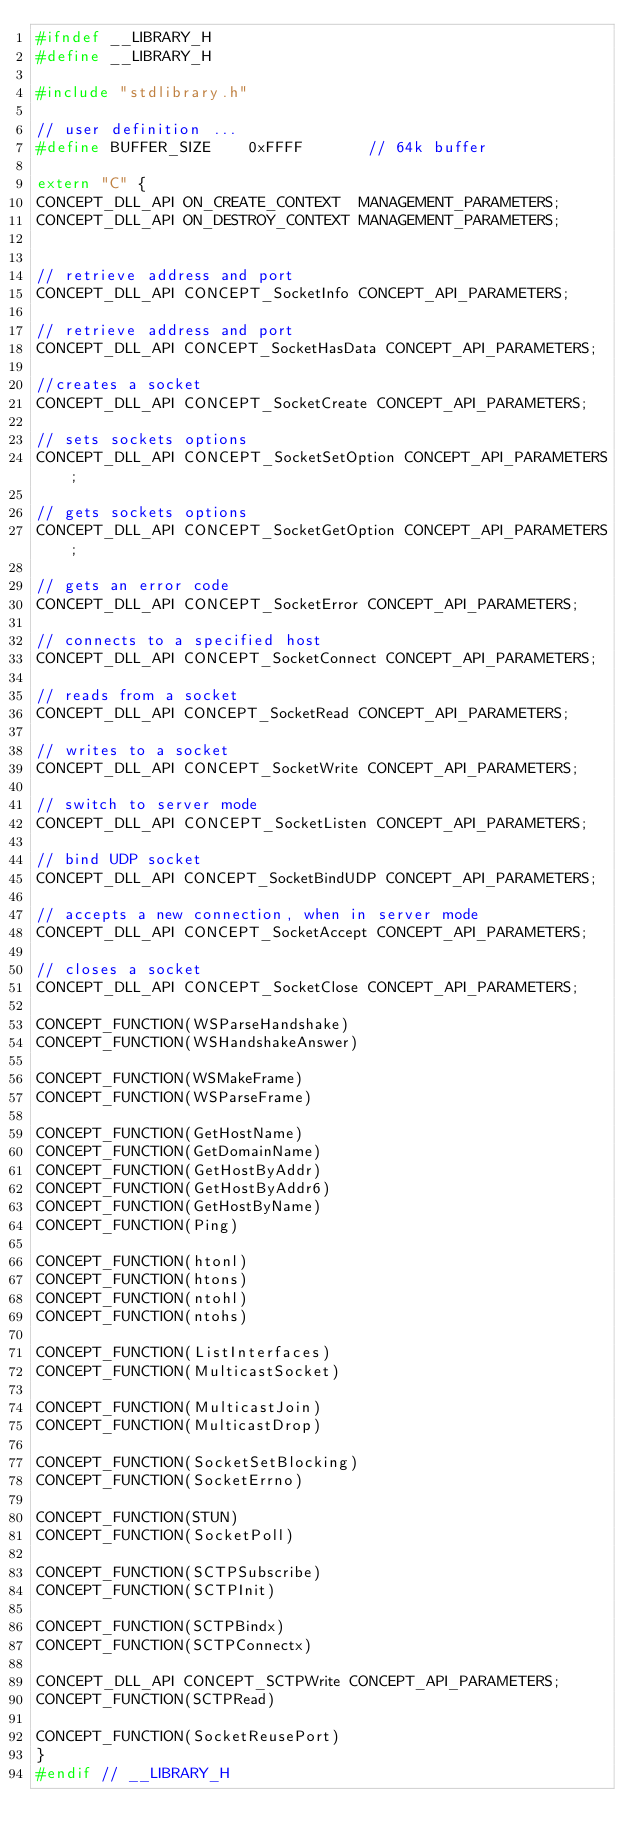Convert code to text. <code><loc_0><loc_0><loc_500><loc_500><_C_>#ifndef __LIBRARY_H
#define __LIBRARY_H

#include "stdlibrary.h"

// user definition ...
#define BUFFER_SIZE    0xFFFF       // 64k buffer

extern "C" {
CONCEPT_DLL_API ON_CREATE_CONTEXT  MANAGEMENT_PARAMETERS;
CONCEPT_DLL_API ON_DESTROY_CONTEXT MANAGEMENT_PARAMETERS;


// retrieve address and port
CONCEPT_DLL_API CONCEPT_SocketInfo CONCEPT_API_PARAMETERS;

// retrieve address and port
CONCEPT_DLL_API CONCEPT_SocketHasData CONCEPT_API_PARAMETERS;

//creates a socket
CONCEPT_DLL_API CONCEPT_SocketCreate CONCEPT_API_PARAMETERS;

// sets sockets options
CONCEPT_DLL_API CONCEPT_SocketSetOption CONCEPT_API_PARAMETERS;

// gets sockets options
CONCEPT_DLL_API CONCEPT_SocketGetOption CONCEPT_API_PARAMETERS;

// gets an error code
CONCEPT_DLL_API CONCEPT_SocketError CONCEPT_API_PARAMETERS;

// connects to a specified host
CONCEPT_DLL_API CONCEPT_SocketConnect CONCEPT_API_PARAMETERS;

// reads from a socket
CONCEPT_DLL_API CONCEPT_SocketRead CONCEPT_API_PARAMETERS;

// writes to a socket
CONCEPT_DLL_API CONCEPT_SocketWrite CONCEPT_API_PARAMETERS;

// switch to server mode
CONCEPT_DLL_API CONCEPT_SocketListen CONCEPT_API_PARAMETERS;

// bind UDP socket
CONCEPT_DLL_API CONCEPT_SocketBindUDP CONCEPT_API_PARAMETERS;

// accepts a new connection, when in server mode
CONCEPT_DLL_API CONCEPT_SocketAccept CONCEPT_API_PARAMETERS;

// closes a socket
CONCEPT_DLL_API CONCEPT_SocketClose CONCEPT_API_PARAMETERS;

CONCEPT_FUNCTION(WSParseHandshake)
CONCEPT_FUNCTION(WSHandshakeAnswer)

CONCEPT_FUNCTION(WSMakeFrame)
CONCEPT_FUNCTION(WSParseFrame)

CONCEPT_FUNCTION(GetHostName)
CONCEPT_FUNCTION(GetDomainName)
CONCEPT_FUNCTION(GetHostByAddr)
CONCEPT_FUNCTION(GetHostByAddr6)
CONCEPT_FUNCTION(GetHostByName)
CONCEPT_FUNCTION(Ping)

CONCEPT_FUNCTION(htonl)
CONCEPT_FUNCTION(htons)
CONCEPT_FUNCTION(ntohl)
CONCEPT_FUNCTION(ntohs)

CONCEPT_FUNCTION(ListInterfaces)
CONCEPT_FUNCTION(MulticastSocket)

CONCEPT_FUNCTION(MulticastJoin)
CONCEPT_FUNCTION(MulticastDrop)

CONCEPT_FUNCTION(SocketSetBlocking)
CONCEPT_FUNCTION(SocketErrno)

CONCEPT_FUNCTION(STUN)
CONCEPT_FUNCTION(SocketPoll)

CONCEPT_FUNCTION(SCTPSubscribe)
CONCEPT_FUNCTION(SCTPInit)

CONCEPT_FUNCTION(SCTPBindx)
CONCEPT_FUNCTION(SCTPConnectx)

CONCEPT_DLL_API CONCEPT_SCTPWrite CONCEPT_API_PARAMETERS;
CONCEPT_FUNCTION(SCTPRead)

CONCEPT_FUNCTION(SocketReusePort)
}
#endif // __LIBRARY_H
</code> 